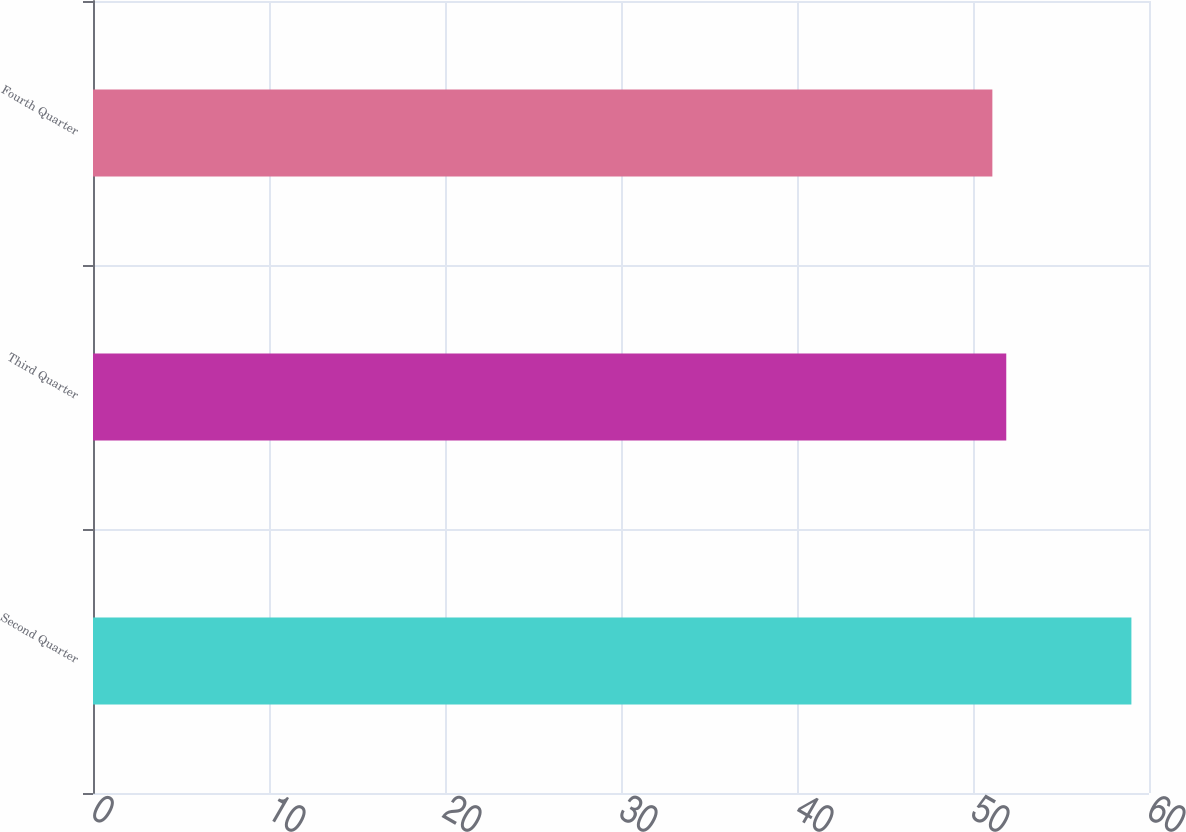Convert chart to OTSL. <chart><loc_0><loc_0><loc_500><loc_500><bar_chart><fcel>Second Quarter<fcel>Third Quarter<fcel>Fourth Quarter<nl><fcel>59<fcel>51.89<fcel>51.1<nl></chart> 